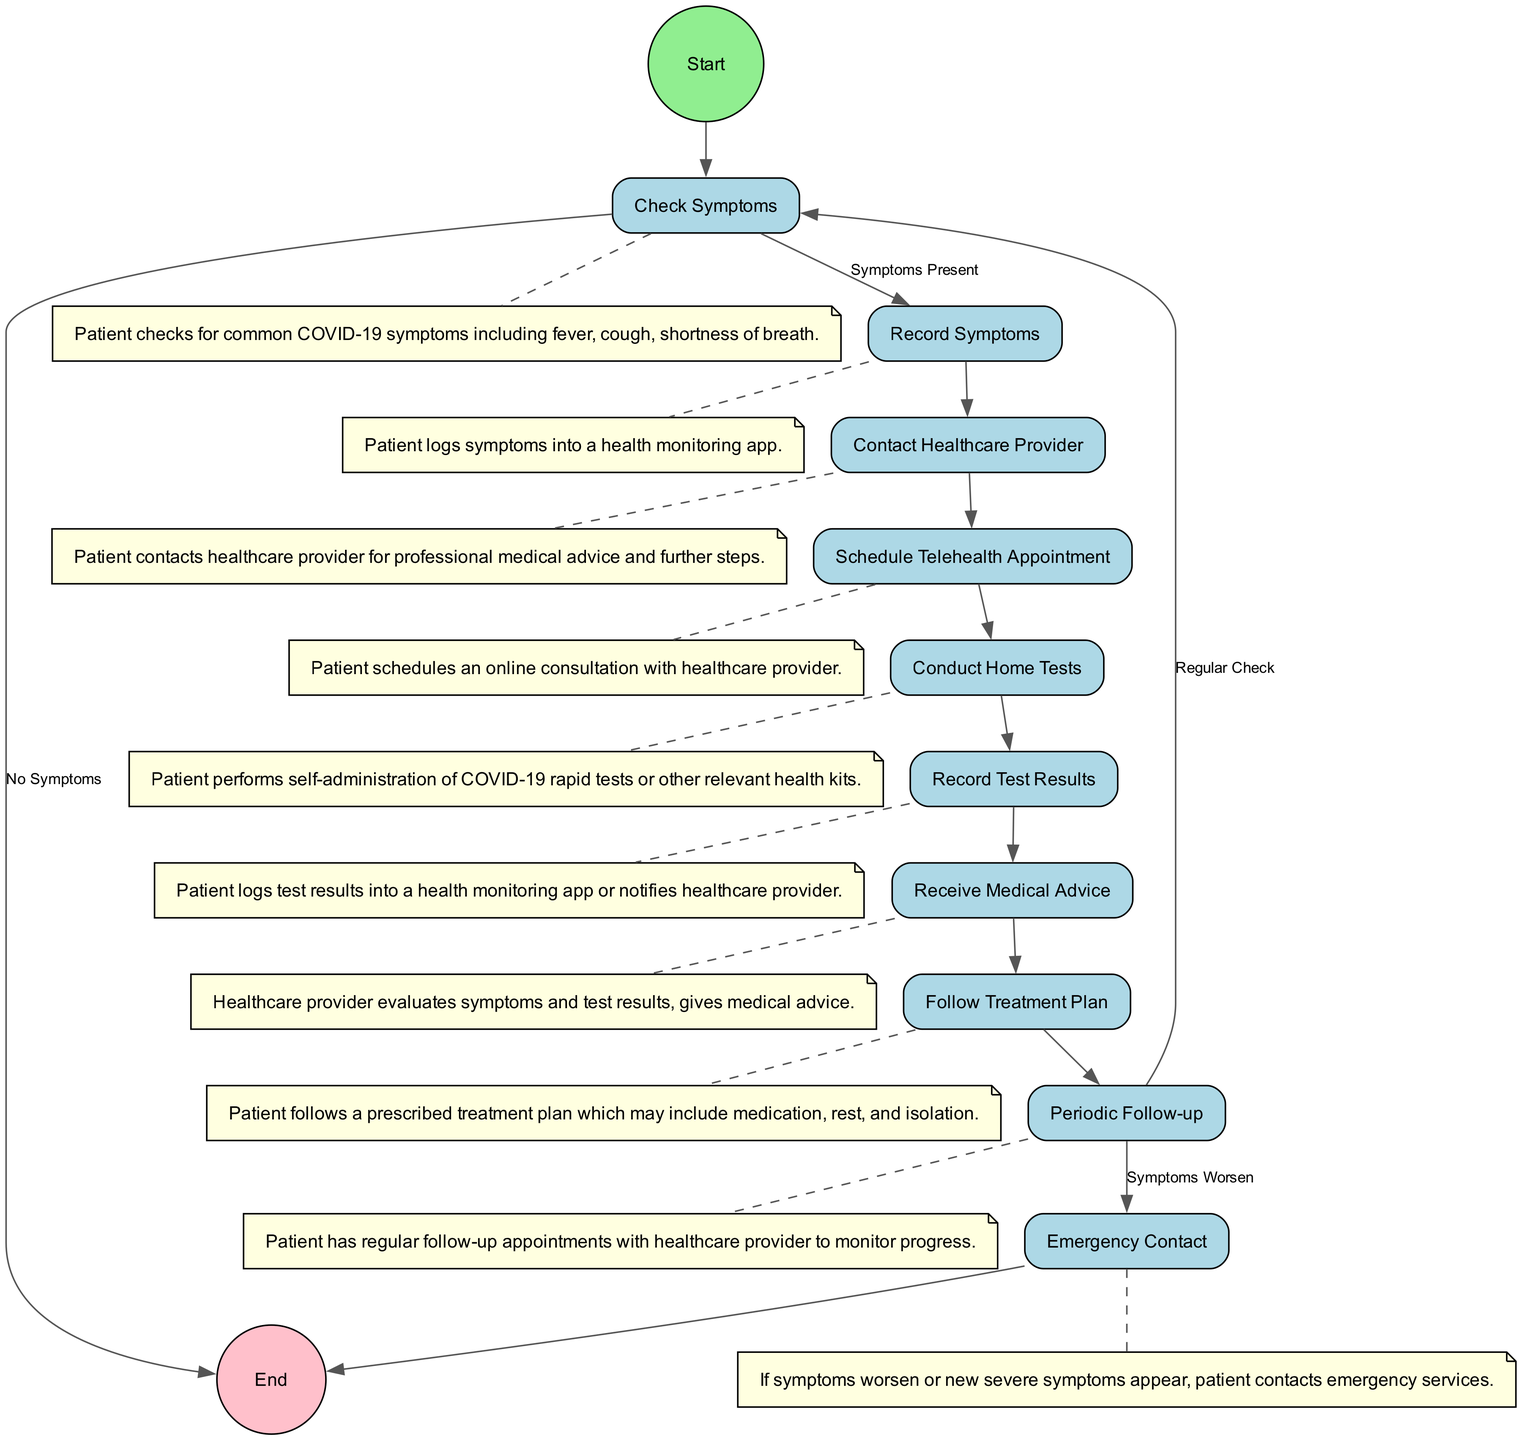What is the first action in the diagram? The diagram starts with a node labeled "Start," followed by the action "Check Symptoms." This establishes the beginning of the health monitoring process.
Answer: Check Symptoms How many actions does the patient have to perform after checking symptoms if symptoms are present? After checking for symptoms, if they are present, the next action is to record symptoms. Following that, the patient contacts a healthcare provider, schedules a telehealth appointment, conducts home tests, and records test results. Counting these actions gives a total of 5 actions.
Answer: 5 What happens if the patient does not have any symptoms? If the patient has no symptoms, the flow of the diagram indicates that the next step is to move to the "End" node, which signifies the termination of the monitoring process without further actions.
Answer: End What type of contact does the patient have with a healthcare provider after recording symptoms? After the patient records symptoms, the next action in the diagram is to "Contact Healthcare Provider," indicating a professional interaction for medical advice.
Answer: Contact Healthcare Provider What action follows "Receive Medical Advice"? The next action after "Receive Medical Advice" is to "Follow Treatment Plan," which entails adhering to the healthcare provider's recommendations based on the patient's symptoms and test results.
Answer: Follow Treatment Plan How many different paths can the patient take after periodic follow-up? After "Periodic Follow-up," the patient can follow two different paths: one leads to "Check Symptoms" for a regular check, and the other leads to "Emergency Contact" if symptoms worsen. This indicates two distinct possibilities based on the patient's condition.
Answer: 2 What indicates that immediate action is required? The diagram specifies that if symptoms worsen or new severe symptoms appear, the patient should take the action labeled "Emergency Contact," which suggests that immediate medical assistance is necessary under those conditions.
Answer: Emergency Contact What must the patient do after conducting home tests? Once the patient completes conducting home tests, the next step outlined in the diagram is to "Record Test Results," which involves logging the outcomes of their home tests into the appropriate health monitoring system.
Answer: Record Test Results What is the last action in the health monitoring process? The final action depicted in the diagram is labeled "End," indicating that the health monitoring process concludes here, either after the patient has followed the treatment plan or in cases where no symptoms are present.
Answer: End 